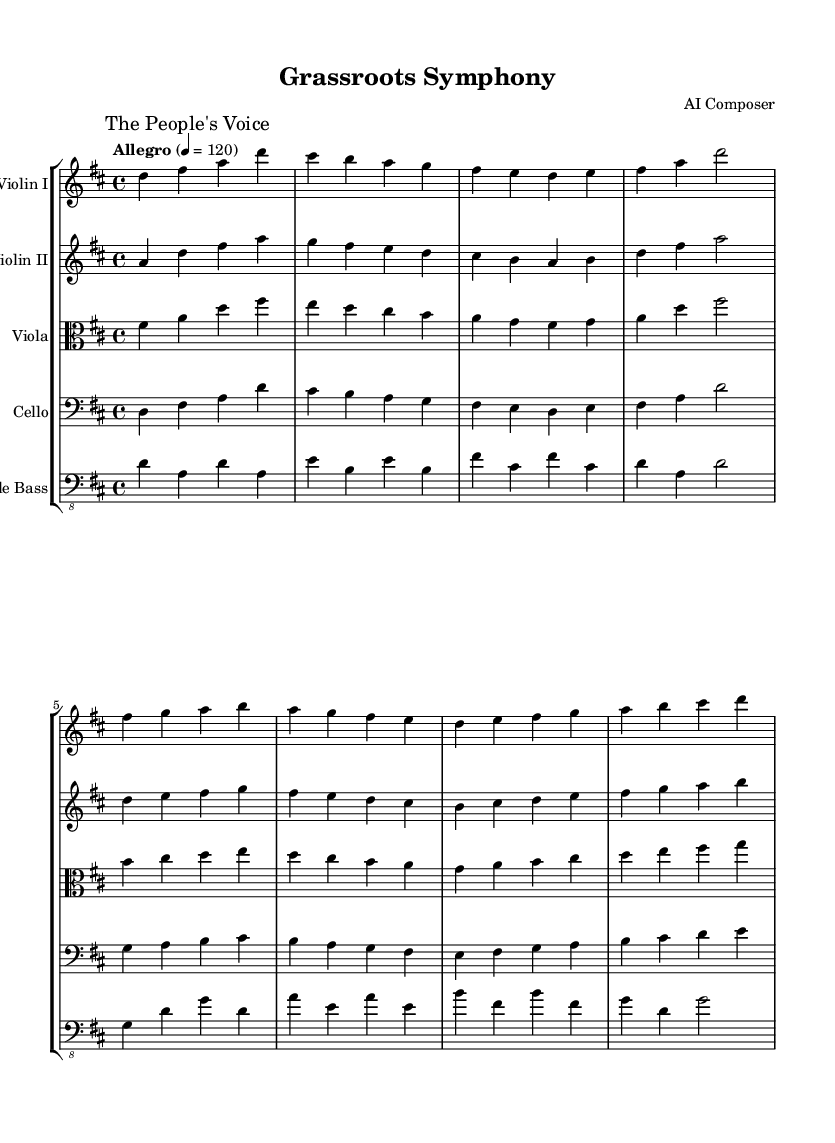What is the key signature of this music? The key signature is D major, which has two sharps (F# and C#). You can identify the key signature at the beginning of the staff, where the sharps are indicated.
Answer: D major What is the time signature of this piece? The time signature is 4/4, which means there are four beats in each measure and the quarter note receives one beat. This can be found just after the key signature at the start of the first staff.
Answer: 4/4 What is the tempo marking for this symphony? The tempo marking indicates "Allegro", which means the piece should be played at a lively and fast pace. The tempo is specified directly in the sheet music.
Answer: Allegro How many different instruments are included in this score? There are five different instruments in the score, as indicated by separate staffs for each instrument listed under the staff group. The instruments are Violin I, Violin II, Viola, Cello, and Double Bass.
Answer: Five Which section of the symphony is marked as "The People's Voice"? "The People's Voice" is marked at the beginning of the Violin I part, indicating that this section carries the thematic material representing the community's spirit. This marking can be seen as an expressive directive in the music notation.
Answer: The People's Voice What is the lowest instrument in this symphony? The lowest instrument is the Double Bass, as indicated by its assigned staff with a bass clef, which signifies that the notes played have a lower pitch range compared to the other instruments.
Answer: Double Bass 